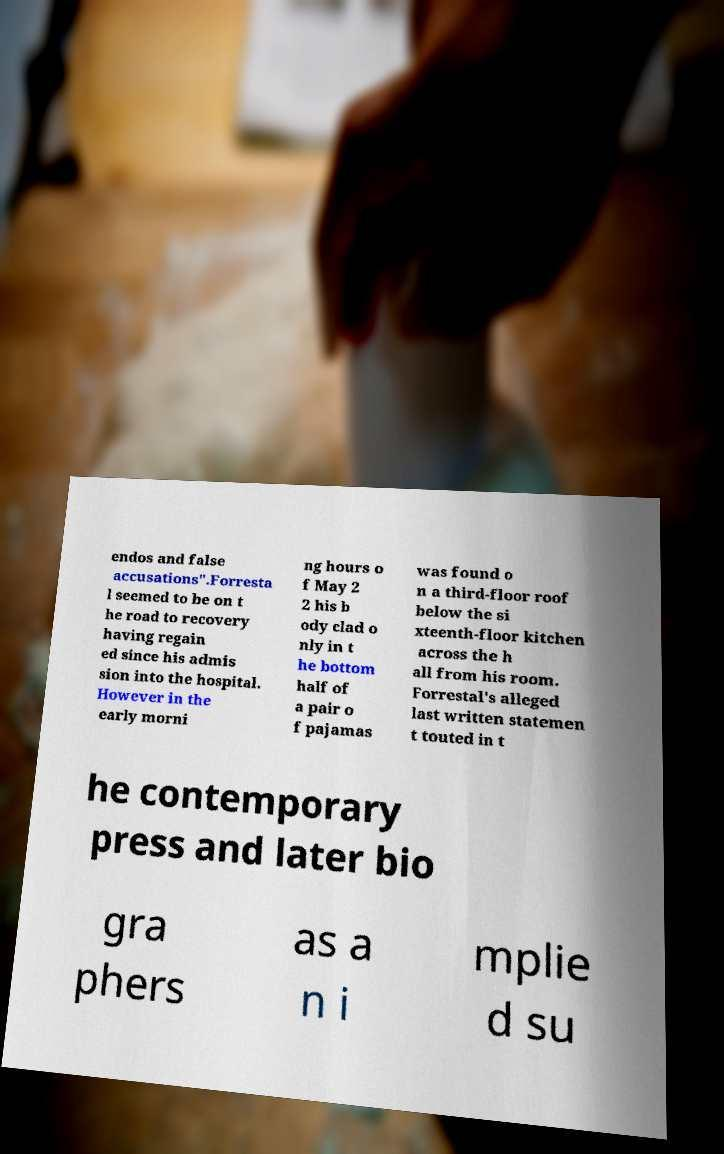Please identify and transcribe the text found in this image. endos and false accusations".Forresta l seemed to be on t he road to recovery having regain ed since his admis sion into the hospital. However in the early morni ng hours o f May 2 2 his b ody clad o nly in t he bottom half of a pair o f pajamas was found o n a third-floor roof below the si xteenth-floor kitchen across the h all from his room. Forrestal's alleged last written statemen t touted in t he contemporary press and later bio gra phers as a n i mplie d su 